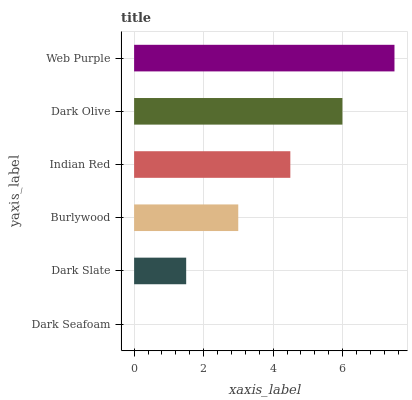Is Dark Seafoam the minimum?
Answer yes or no. Yes. Is Web Purple the maximum?
Answer yes or no. Yes. Is Dark Slate the minimum?
Answer yes or no. No. Is Dark Slate the maximum?
Answer yes or no. No. Is Dark Slate greater than Dark Seafoam?
Answer yes or no. Yes. Is Dark Seafoam less than Dark Slate?
Answer yes or no. Yes. Is Dark Seafoam greater than Dark Slate?
Answer yes or no. No. Is Dark Slate less than Dark Seafoam?
Answer yes or no. No. Is Indian Red the high median?
Answer yes or no. Yes. Is Burlywood the low median?
Answer yes or no. Yes. Is Dark Slate the high median?
Answer yes or no. No. Is Indian Red the low median?
Answer yes or no. No. 